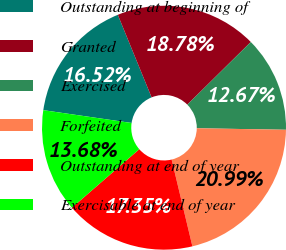<chart> <loc_0><loc_0><loc_500><loc_500><pie_chart><fcel>Outstanding at beginning of<fcel>Granted<fcel>Exercised<fcel>Forfeited<fcel>Outstanding at end of year<fcel>Exercisable at end of year<nl><fcel>16.52%<fcel>18.78%<fcel>12.67%<fcel>20.99%<fcel>17.35%<fcel>13.68%<nl></chart> 